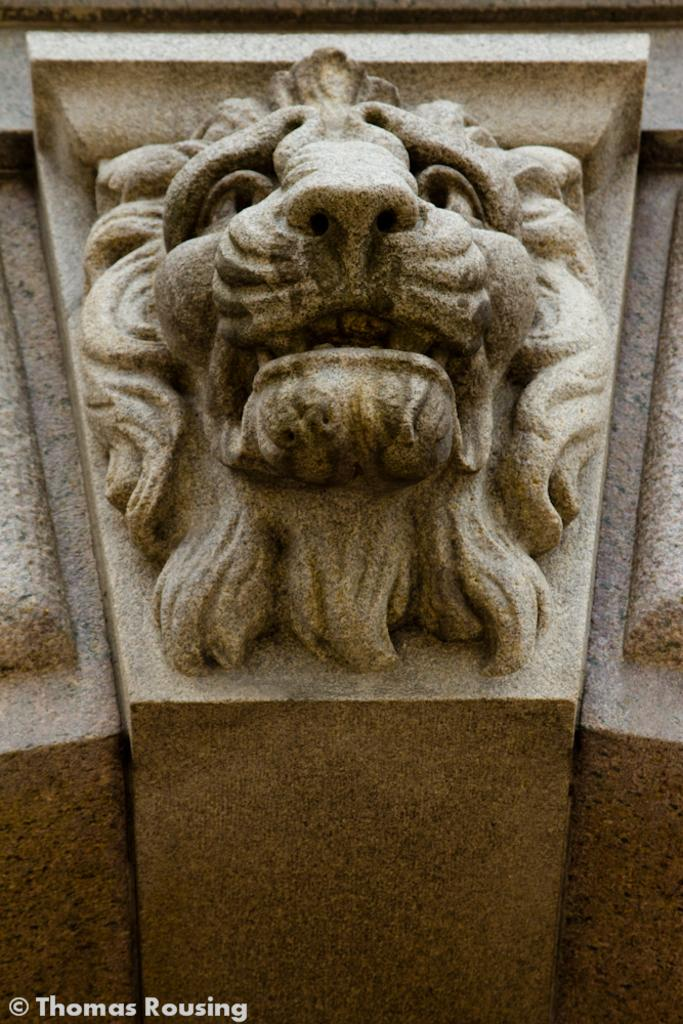What can be seen on the wall in the image? There are carvings on the wall in the image. Is there any additional information or markings in the image? Yes, there is a watermark in the bottom left corner of the image. How many kittens are playing with the cloth in the image? There are no kittens or cloth present in the image. Can you describe the kick of the person in the image? There is no person or kick present in the image. 